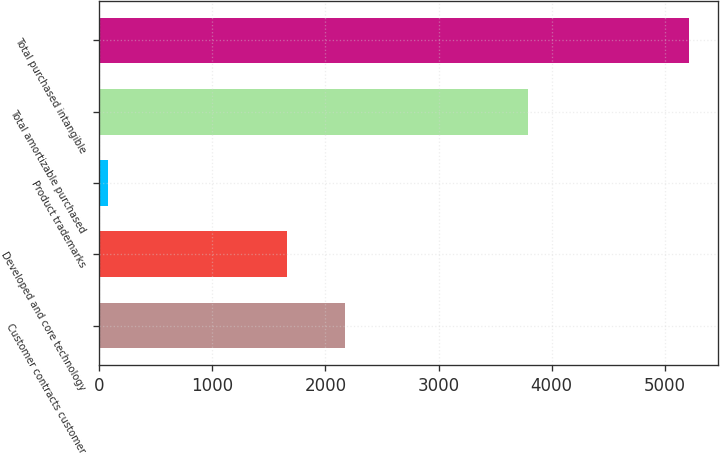Convert chart. <chart><loc_0><loc_0><loc_500><loc_500><bar_chart><fcel>Customer contracts customer<fcel>Developed and core technology<fcel>Product trademarks<fcel>Total amortizable purchased<fcel>Total purchased intangible<nl><fcel>2175.5<fcel>1663<fcel>84<fcel>3787<fcel>5209<nl></chart> 